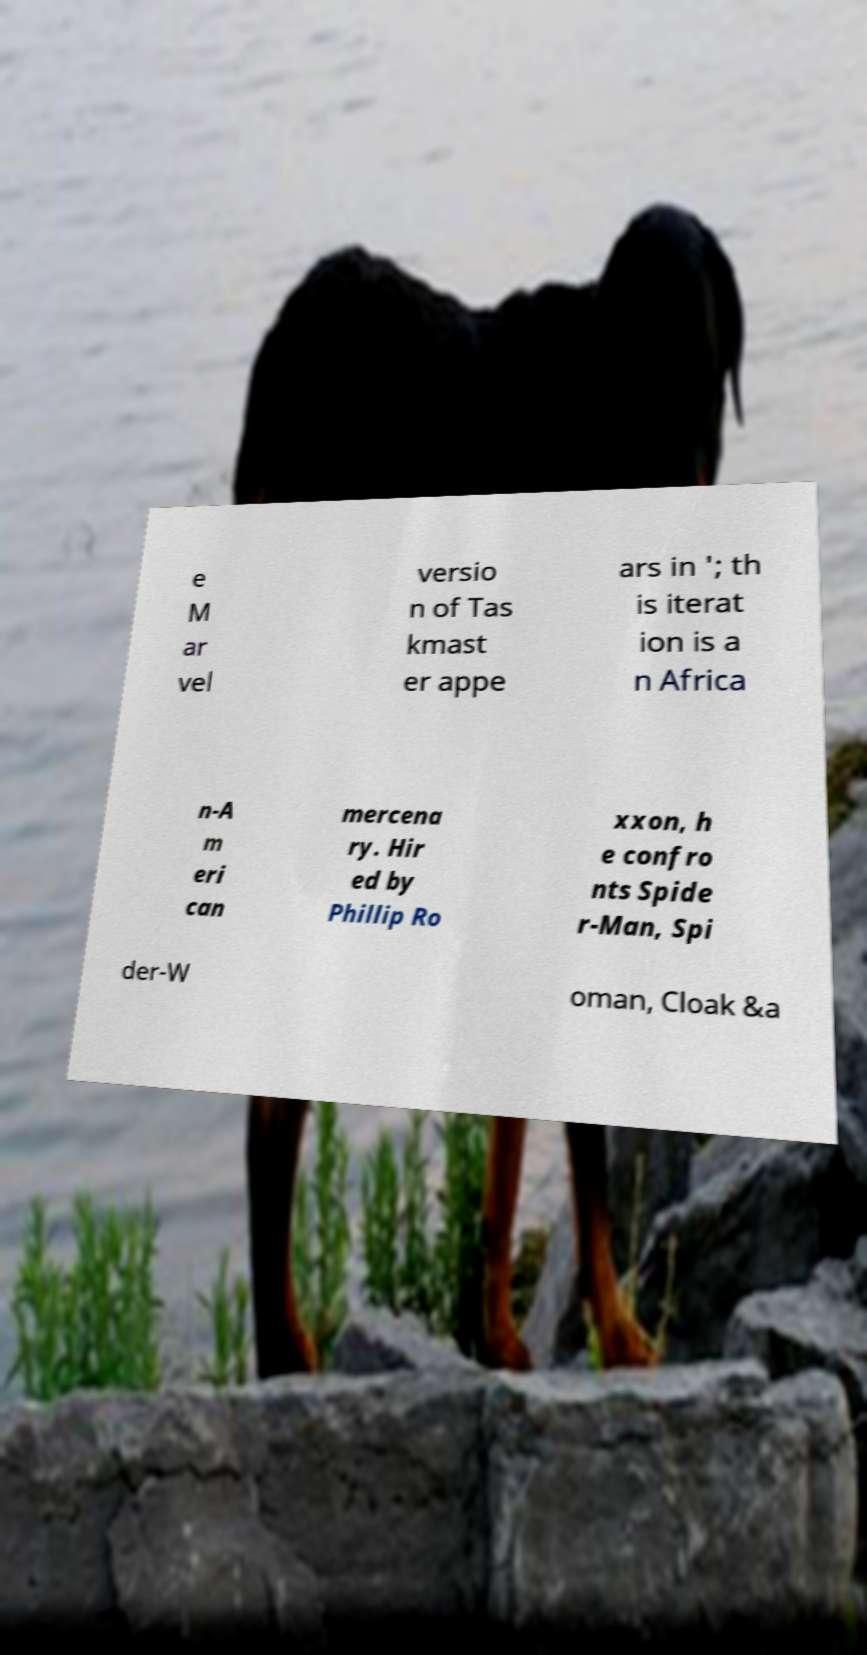For documentation purposes, I need the text within this image transcribed. Could you provide that? e M ar vel versio n of Tas kmast er appe ars in '; th is iterat ion is a n Africa n-A m eri can mercena ry. Hir ed by Phillip Ro xxon, h e confro nts Spide r-Man, Spi der-W oman, Cloak &a 